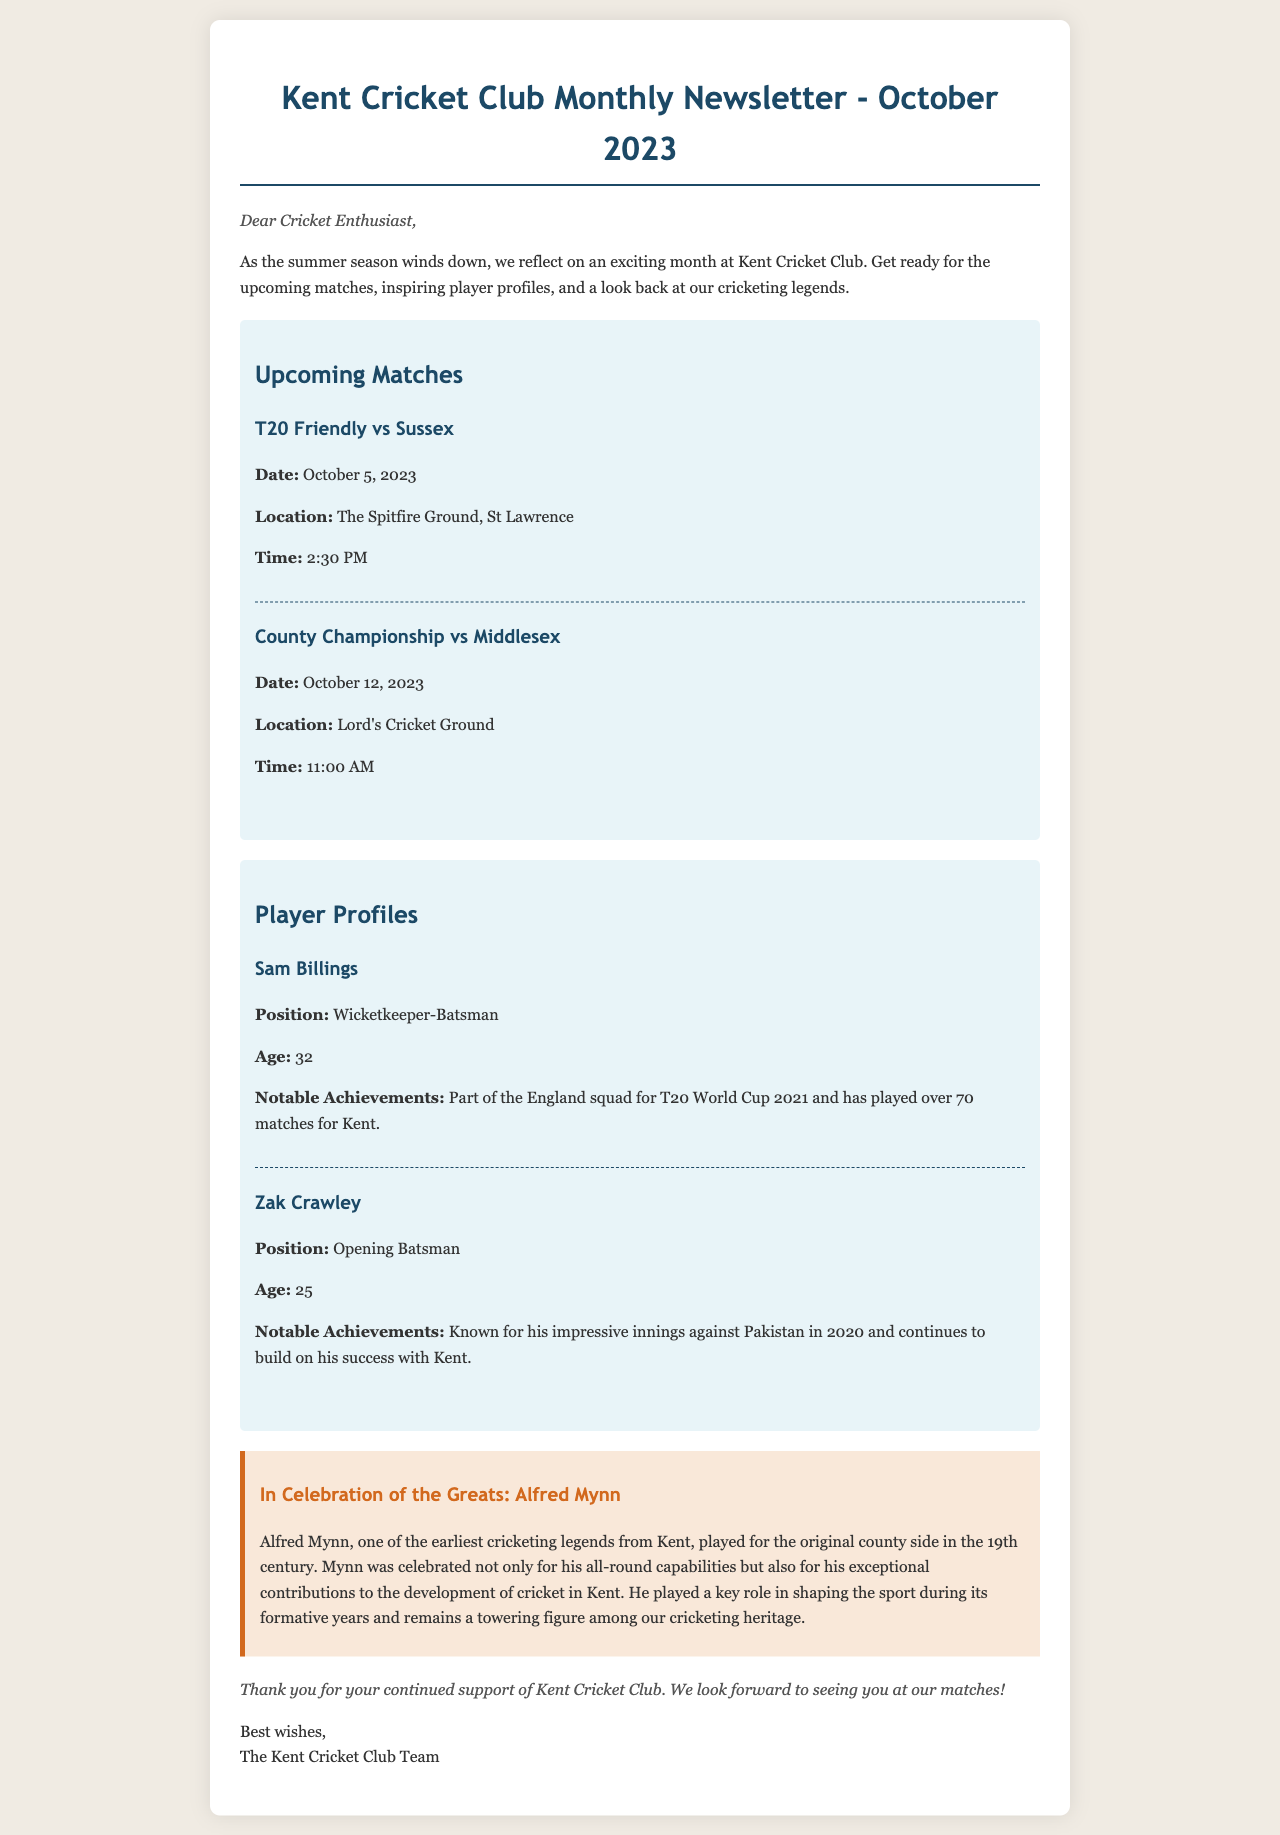what is the publication date of the newsletter? The publication date is mentioned clearly at the top of the newsletter as October 2023.
Answer: October 2023 how many upcoming matches are listed? The document specifies two upcoming matches in the matches section.
Answer: 2 who is the wicketkeeper-batsman featured in the player profiles? The newsletter includes Sam Billings as the highlighted wicketkeeper-batsman in the player profiles section.
Answer: Sam Billings what is the time of the T20 Friendly match against Sussex? The time of the T20 Friendly against Sussex is indicated in the matches section of the document.
Answer: 2:30 PM what notable achievement is listed for Zak Crawley? The newsletter mentions Zak Crawley's impressive innings against Pakistan in 2020 as a notable achievement in his profile.
Answer: Impressive innings against Pakistan in 2020 which player profile includes an age of 32? The document states that Sam Billings is 32 years old in his player profile.
Answer: Sam Billings who is highlighted in the historical section? The historical highlight section mentions Alfred Mynn as a celebrated cricketing legend.
Answer: Alfred Mynn where will the County Championship match take place? The location for the County Championship match is provided in the matches section of the document.
Answer: Lord's Cricket Ground 